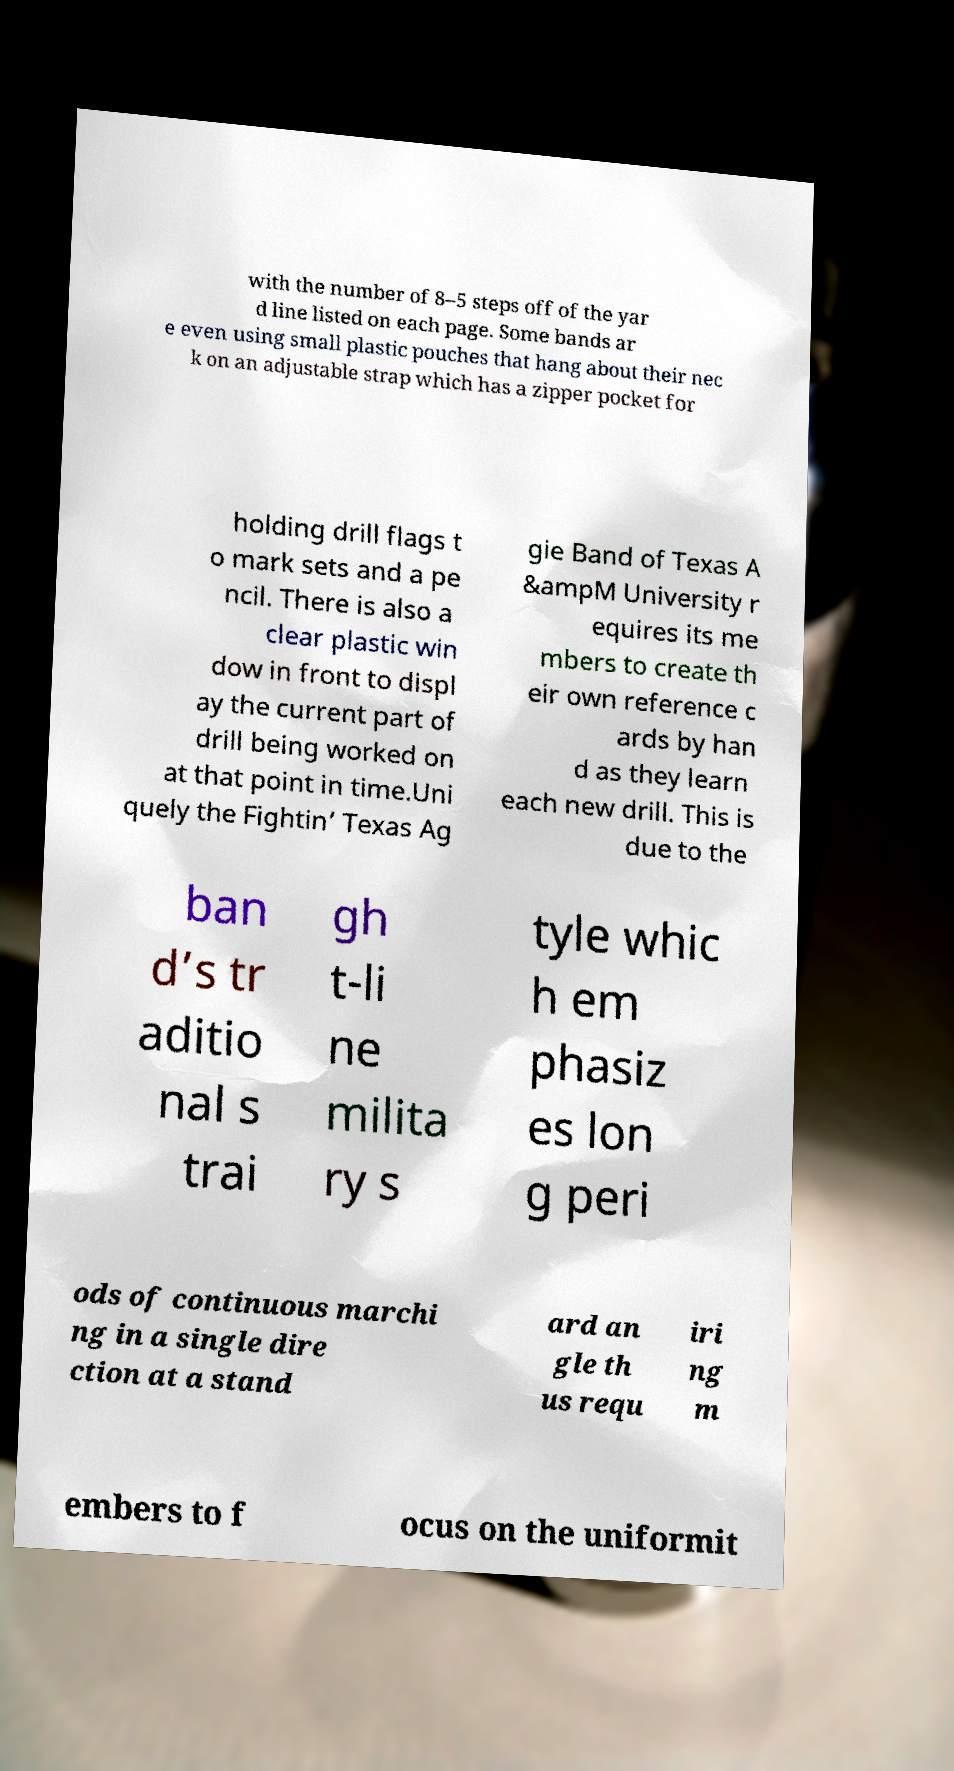For documentation purposes, I need the text within this image transcribed. Could you provide that? with the number of 8–5 steps off of the yar d line listed on each page. Some bands ar e even using small plastic pouches that hang about their nec k on an adjustable strap which has a zipper pocket for holding drill flags t o mark sets and a pe ncil. There is also a clear plastic win dow in front to displ ay the current part of drill being worked on at that point in time.Uni quely the Fightin’ Texas Ag gie Band of Texas A &ampM University r equires its me mbers to create th eir own reference c ards by han d as they learn each new drill. This is due to the ban d’s tr aditio nal s trai gh t-li ne milita ry s tyle whic h em phasiz es lon g peri ods of continuous marchi ng in a single dire ction at a stand ard an gle th us requ iri ng m embers to f ocus on the uniformit 